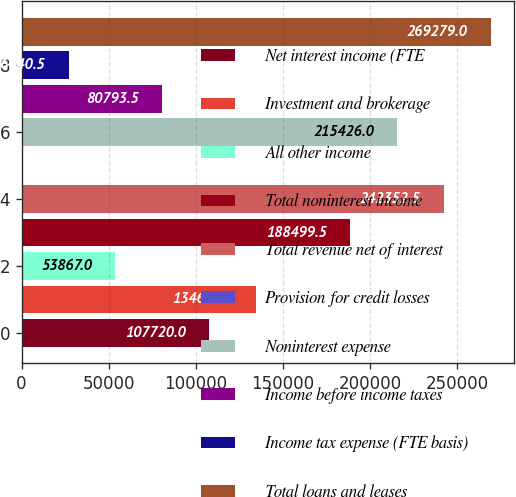Convert chart. <chart><loc_0><loc_0><loc_500><loc_500><bar_chart><fcel>Net interest income (FTE<fcel>Investment and brokerage<fcel>All other income<fcel>Total noninterest income<fcel>Total revenue net of interest<fcel>Provision for credit losses<fcel>Noninterest expense<fcel>Income before income taxes<fcel>Income tax expense (FTE basis)<fcel>Total loans and leases<nl><fcel>107720<fcel>134646<fcel>53867<fcel>188500<fcel>242352<fcel>14<fcel>215426<fcel>80793.5<fcel>26940.5<fcel>269279<nl></chart> 